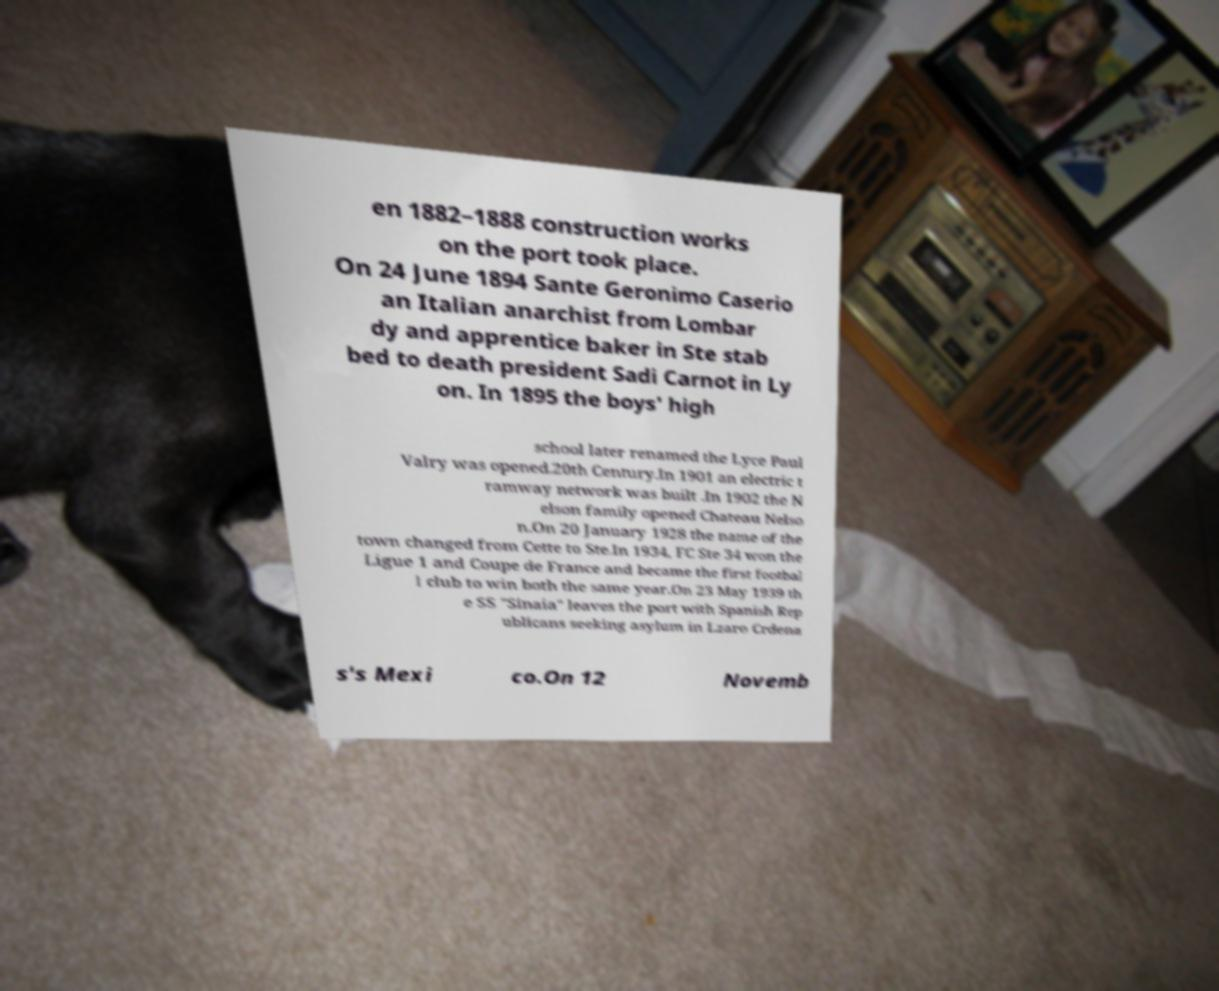Please read and relay the text visible in this image. What does it say? en 1882–1888 construction works on the port took place. On 24 June 1894 Sante Geronimo Caserio an Italian anarchist from Lombar dy and apprentice baker in Ste stab bed to death president Sadi Carnot in Ly on. In 1895 the boys' high school later renamed the Lyce Paul Valry was opened.20th Century.In 1901 an electric t ramway network was built .In 1902 the N elson family opened Chateau Nelso n.On 20 January 1928 the name of the town changed from Cette to Ste.In 1934, FC Ste 34 won the Ligue 1 and Coupe de France and became the first footbal l club to win both the same year.On 23 May 1939 th e SS "Sinaia" leaves the port with Spanish Rep ublicans seeking asylum in Lzaro Crdena s's Mexi co.On 12 Novemb 